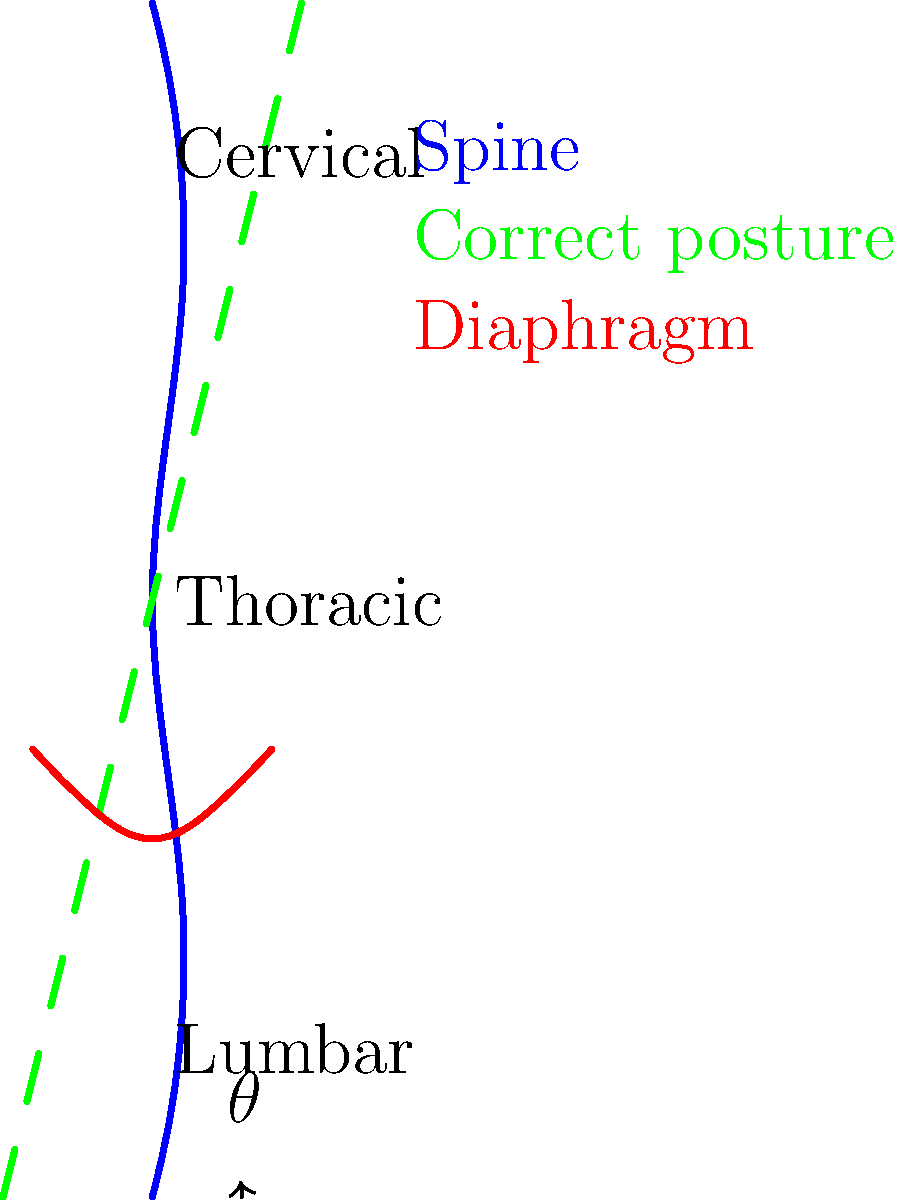In the diagram, the green dashed line represents the ideal posture for optimal breath control during rap performance. What is the approximate angle $\theta$ between the spine's base and the vertical axis that allows for the most efficient diaphragm expansion and contraction? To determine the optimal angle for breath control during rap performance, we need to consider the following factors:

1. Spinal alignment: The green dashed line shows the ideal posture, which is slightly tilted forward from a perfectly vertical position.

2. Diaphragm position: The red curve represents the diaphragm, which is crucial for breath control.

3. Lumbar curve: The lower part of the spine (lumbar region) should maintain a slight natural curve.

4. Angle measurement: The angle $\theta$ is formed between the base of the spine and the vertical axis.

5. Biomechanical efficiency: A slight forward tilt allows for better engagement of the core muscles and more efficient diaphragm movement.

6. Practical considerations: The angle should not be too large, as this would create tension and restrict breathing.

7. Optimal range: Based on biomechanical studies of singers and wind instrument players, the ideal angle typically falls between 5° and 15°.

8. Visual estimation: From the diagram, we can see that the angle appears to be approximately 10°, which falls within the optimal range.

This slight forward tilt allows for:
a) Better engagement of core muscles
b) More efficient diaphragm contraction and expansion
c) Improved breath support and control
d) Reduced tension in the neck and shoulders

Therefore, the optimal angle $\theta$ for breath control during rap performance is approximately 10°.
Answer: Approximately 10° 